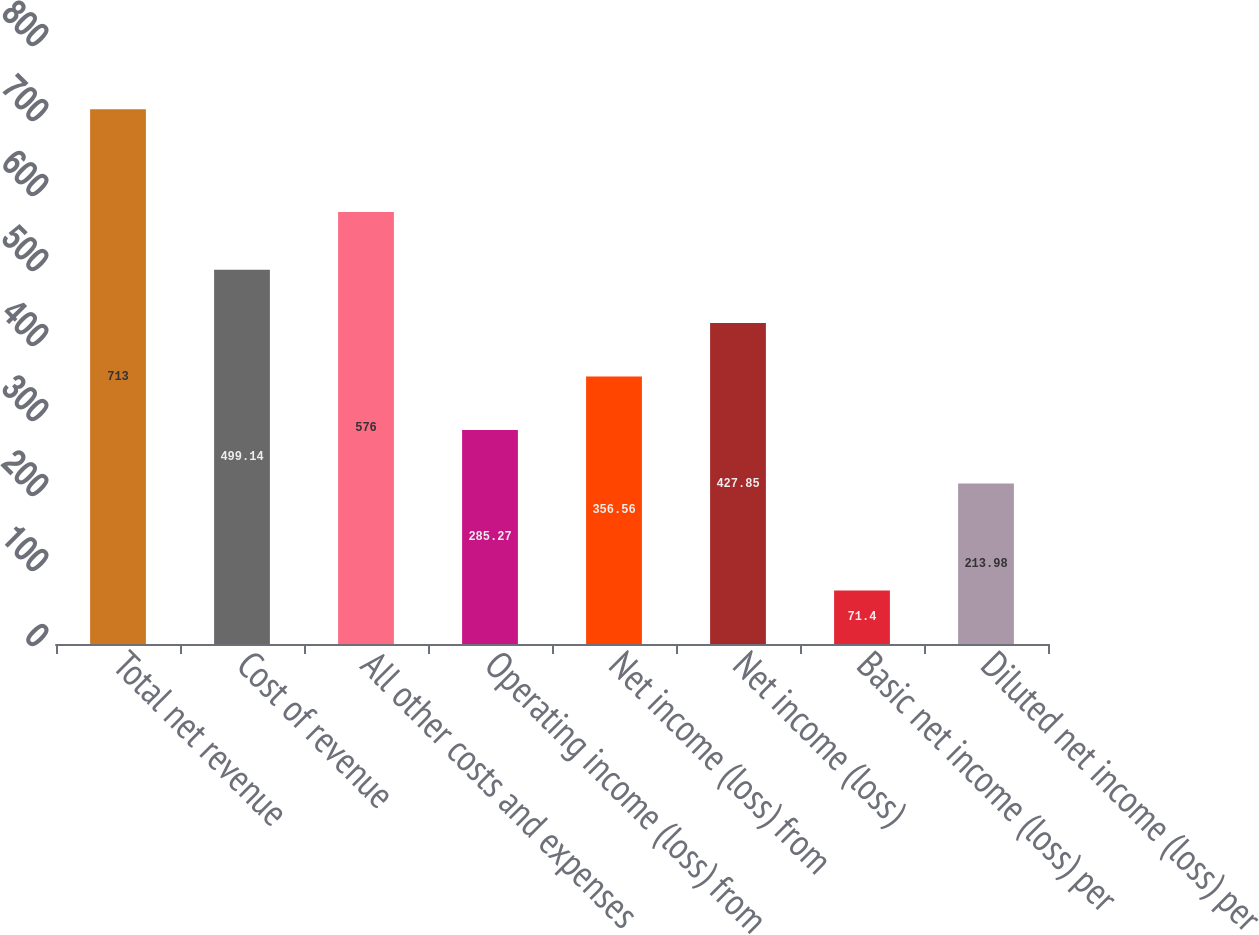<chart> <loc_0><loc_0><loc_500><loc_500><bar_chart><fcel>Total net revenue<fcel>Cost of revenue<fcel>All other costs and expenses<fcel>Operating income (loss) from<fcel>Net income (loss) from<fcel>Net income (loss)<fcel>Basic net income (loss) per<fcel>Diluted net income (loss) per<nl><fcel>713<fcel>499.14<fcel>576<fcel>285.27<fcel>356.56<fcel>427.85<fcel>71.4<fcel>213.98<nl></chart> 